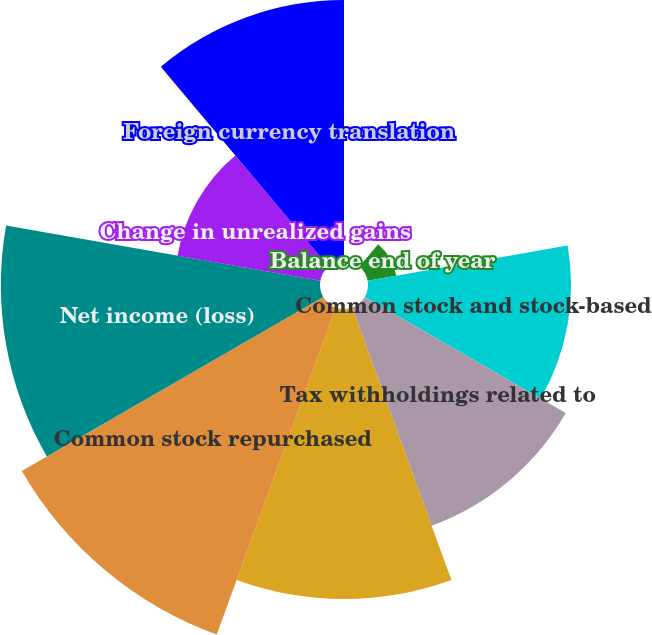<chart> <loc_0><loc_0><loc_500><loc_500><pie_chart><fcel>Balance beginning of year<fcel>Balance end of year<fcel>Common stock and stock-based<fcel>Tax withholdings related to<fcel>Stock-based compensation<fcel>Common stock repurchased<fcel>Net income (loss)<fcel>Change in unrealized gains<fcel>Foreign currency translation<nl><fcel>0.0%<fcel>1.59%<fcel>11.11%<fcel>12.7%<fcel>15.87%<fcel>19.04%<fcel>17.46%<fcel>7.94%<fcel>14.28%<nl></chart> 